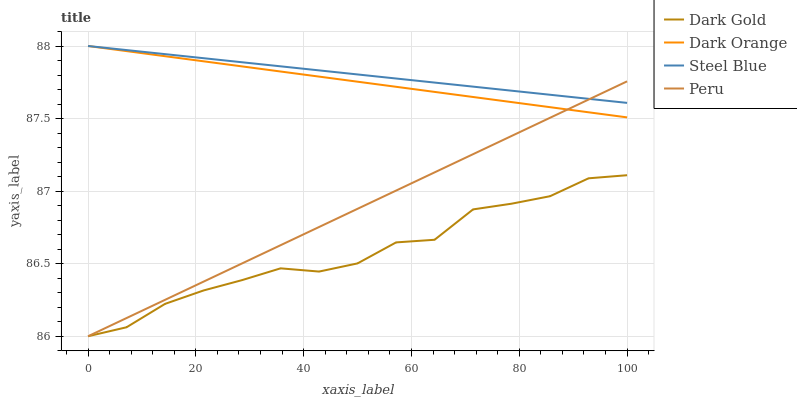Does Dark Gold have the minimum area under the curve?
Answer yes or no. Yes. Does Steel Blue have the maximum area under the curve?
Answer yes or no. Yes. Does Peru have the minimum area under the curve?
Answer yes or no. No. Does Peru have the maximum area under the curve?
Answer yes or no. No. Is Dark Orange the smoothest?
Answer yes or no. Yes. Is Dark Gold the roughest?
Answer yes or no. Yes. Is Steel Blue the smoothest?
Answer yes or no. No. Is Steel Blue the roughest?
Answer yes or no. No. Does Peru have the lowest value?
Answer yes or no. Yes. Does Steel Blue have the lowest value?
Answer yes or no. No. Does Steel Blue have the highest value?
Answer yes or no. Yes. Does Peru have the highest value?
Answer yes or no. No. Is Dark Gold less than Dark Orange?
Answer yes or no. Yes. Is Dark Orange greater than Dark Gold?
Answer yes or no. Yes. Does Steel Blue intersect Dark Orange?
Answer yes or no. Yes. Is Steel Blue less than Dark Orange?
Answer yes or no. No. Is Steel Blue greater than Dark Orange?
Answer yes or no. No. Does Dark Gold intersect Dark Orange?
Answer yes or no. No. 